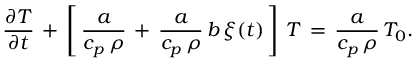Convert formula to latex. <formula><loc_0><loc_0><loc_500><loc_500>\frac { \partial T } { \partial t } \, + \, \left [ \, \frac { a } { c _ { p } \, \rho } \, + \, \frac { a } { c _ { p } \, \rho } \, b \, \xi ( t ) \, \right ] \, T \, = \, \frac { a } { c _ { p } \, \rho } \, T _ { 0 } .</formula> 